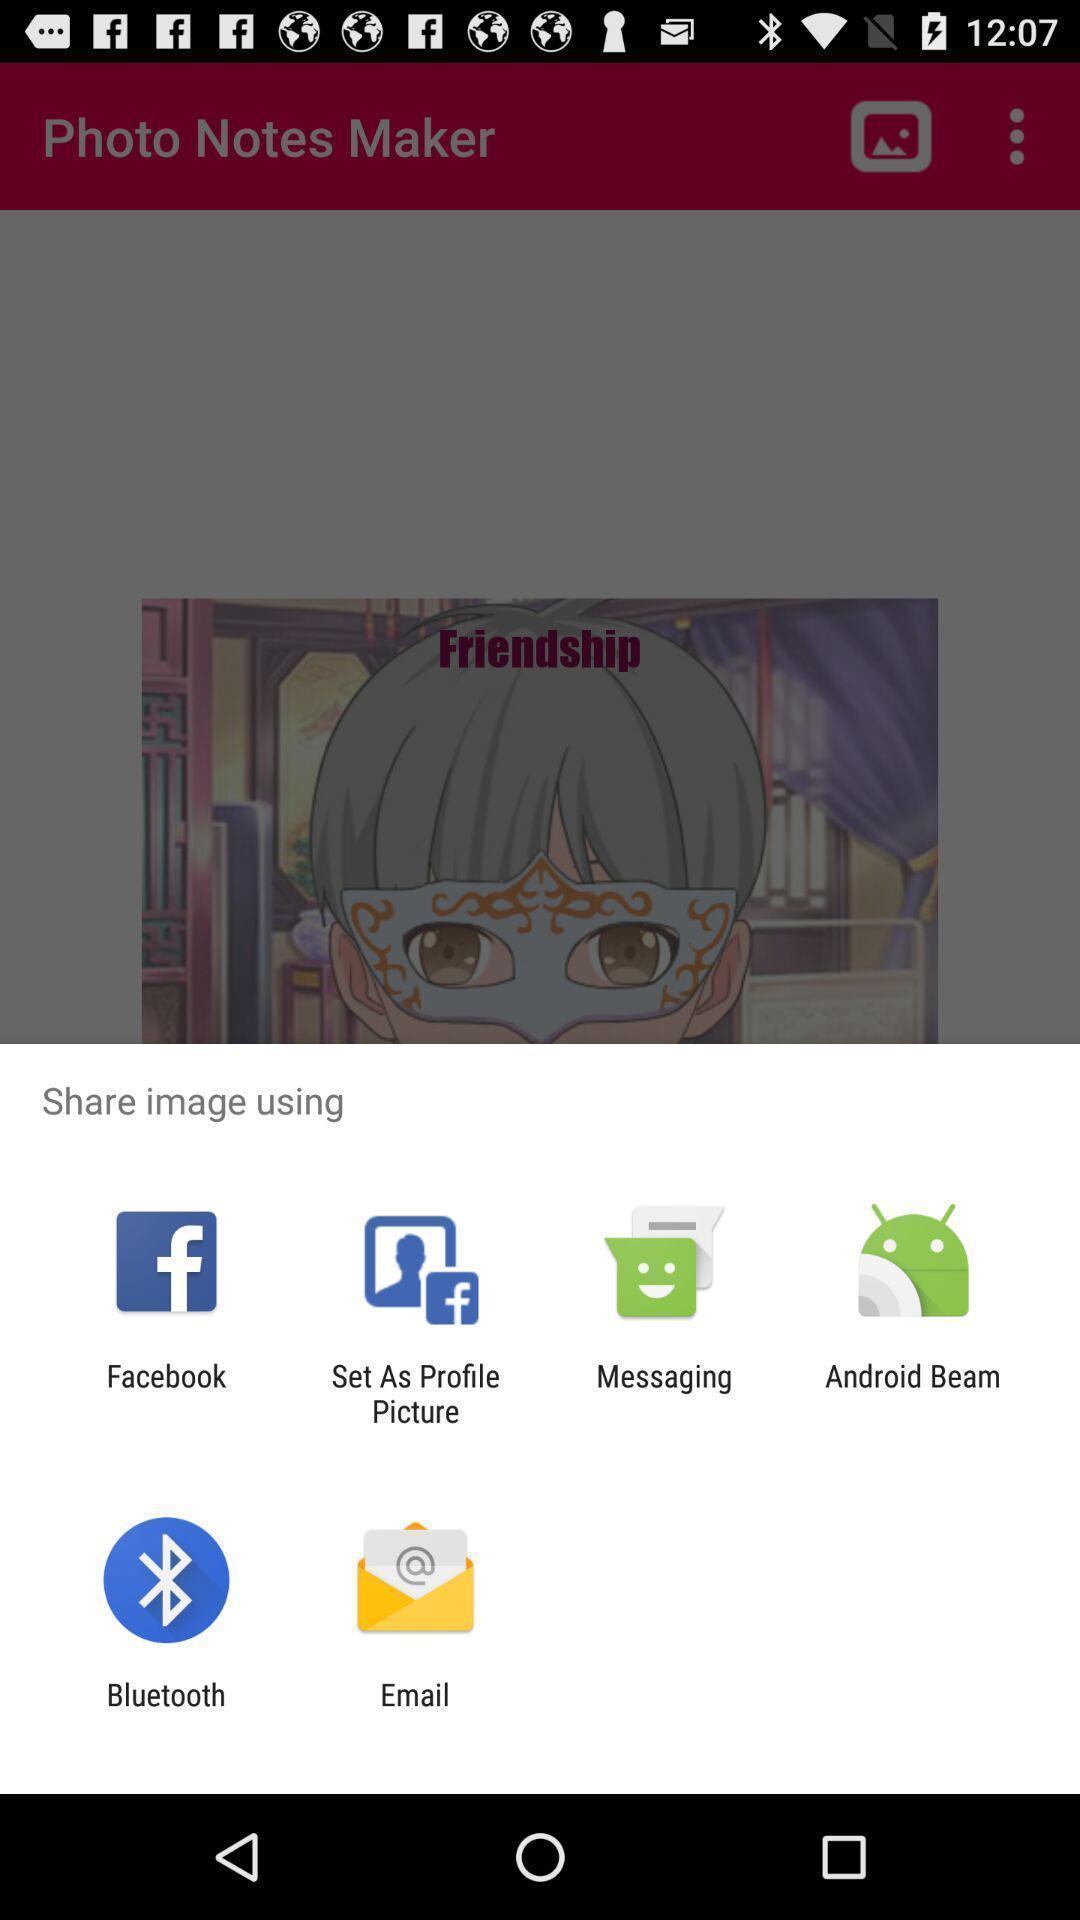Summarize the main components in this picture. Push up page showing app preference to share. 